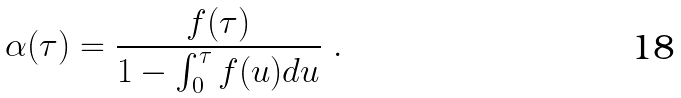<formula> <loc_0><loc_0><loc_500><loc_500>\alpha ( \tau ) = \frac { f ( \tau ) } { 1 - \int _ { 0 } ^ { \tau } f ( u ) d u } \ .</formula> 